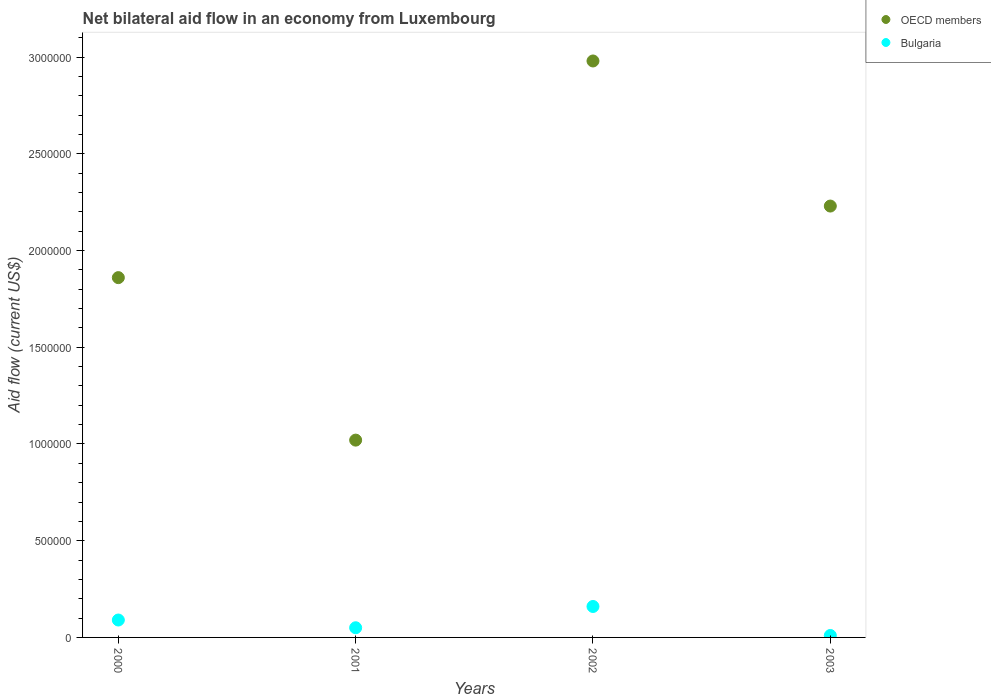How many different coloured dotlines are there?
Provide a short and direct response. 2. Is the number of dotlines equal to the number of legend labels?
Make the answer very short. Yes. What is the net bilateral aid flow in OECD members in 2003?
Provide a succinct answer. 2.23e+06. Across all years, what is the maximum net bilateral aid flow in Bulgaria?
Your answer should be compact. 1.60e+05. Across all years, what is the minimum net bilateral aid flow in Bulgaria?
Your response must be concise. 10000. In which year was the net bilateral aid flow in Bulgaria maximum?
Your answer should be compact. 2002. What is the total net bilateral aid flow in OECD members in the graph?
Provide a succinct answer. 8.09e+06. What is the difference between the net bilateral aid flow in OECD members in 2002 and the net bilateral aid flow in Bulgaria in 2003?
Your answer should be very brief. 2.97e+06. What is the average net bilateral aid flow in Bulgaria per year?
Offer a terse response. 7.75e+04. In the year 2000, what is the difference between the net bilateral aid flow in OECD members and net bilateral aid flow in Bulgaria?
Your answer should be compact. 1.77e+06. In how many years, is the net bilateral aid flow in OECD members greater than 2600000 US$?
Your answer should be very brief. 1. What is the ratio of the net bilateral aid flow in OECD members in 2001 to that in 2003?
Ensure brevity in your answer.  0.46. Is the difference between the net bilateral aid flow in OECD members in 2000 and 2002 greater than the difference between the net bilateral aid flow in Bulgaria in 2000 and 2002?
Your answer should be very brief. No. What is the difference between the highest and the second highest net bilateral aid flow in OECD members?
Ensure brevity in your answer.  7.50e+05. What is the difference between the highest and the lowest net bilateral aid flow in OECD members?
Offer a very short reply. 1.96e+06. Does the net bilateral aid flow in OECD members monotonically increase over the years?
Make the answer very short. No. Is the net bilateral aid flow in Bulgaria strictly greater than the net bilateral aid flow in OECD members over the years?
Make the answer very short. No. How many dotlines are there?
Provide a short and direct response. 2. How many years are there in the graph?
Offer a terse response. 4. What is the difference between two consecutive major ticks on the Y-axis?
Make the answer very short. 5.00e+05. Where does the legend appear in the graph?
Your response must be concise. Top right. How many legend labels are there?
Ensure brevity in your answer.  2. What is the title of the graph?
Your response must be concise. Net bilateral aid flow in an economy from Luxembourg. Does "Spain" appear as one of the legend labels in the graph?
Offer a terse response. No. What is the label or title of the X-axis?
Provide a short and direct response. Years. What is the label or title of the Y-axis?
Keep it short and to the point. Aid flow (current US$). What is the Aid flow (current US$) of OECD members in 2000?
Offer a very short reply. 1.86e+06. What is the Aid flow (current US$) in OECD members in 2001?
Provide a succinct answer. 1.02e+06. What is the Aid flow (current US$) in Bulgaria in 2001?
Your response must be concise. 5.00e+04. What is the Aid flow (current US$) in OECD members in 2002?
Ensure brevity in your answer.  2.98e+06. What is the Aid flow (current US$) in OECD members in 2003?
Your response must be concise. 2.23e+06. What is the Aid flow (current US$) in Bulgaria in 2003?
Make the answer very short. 10000. Across all years, what is the maximum Aid flow (current US$) of OECD members?
Offer a terse response. 2.98e+06. Across all years, what is the minimum Aid flow (current US$) of OECD members?
Your answer should be very brief. 1.02e+06. What is the total Aid flow (current US$) of OECD members in the graph?
Your answer should be very brief. 8.09e+06. What is the total Aid flow (current US$) in Bulgaria in the graph?
Ensure brevity in your answer.  3.10e+05. What is the difference between the Aid flow (current US$) in OECD members in 2000 and that in 2001?
Your answer should be very brief. 8.40e+05. What is the difference between the Aid flow (current US$) of OECD members in 2000 and that in 2002?
Provide a short and direct response. -1.12e+06. What is the difference between the Aid flow (current US$) in OECD members in 2000 and that in 2003?
Offer a very short reply. -3.70e+05. What is the difference between the Aid flow (current US$) of Bulgaria in 2000 and that in 2003?
Ensure brevity in your answer.  8.00e+04. What is the difference between the Aid flow (current US$) of OECD members in 2001 and that in 2002?
Your answer should be very brief. -1.96e+06. What is the difference between the Aid flow (current US$) in Bulgaria in 2001 and that in 2002?
Offer a very short reply. -1.10e+05. What is the difference between the Aid flow (current US$) in OECD members in 2001 and that in 2003?
Give a very brief answer. -1.21e+06. What is the difference between the Aid flow (current US$) in OECD members in 2002 and that in 2003?
Provide a short and direct response. 7.50e+05. What is the difference between the Aid flow (current US$) in OECD members in 2000 and the Aid flow (current US$) in Bulgaria in 2001?
Give a very brief answer. 1.81e+06. What is the difference between the Aid flow (current US$) of OECD members in 2000 and the Aid flow (current US$) of Bulgaria in 2002?
Your response must be concise. 1.70e+06. What is the difference between the Aid flow (current US$) of OECD members in 2000 and the Aid flow (current US$) of Bulgaria in 2003?
Offer a very short reply. 1.85e+06. What is the difference between the Aid flow (current US$) in OECD members in 2001 and the Aid flow (current US$) in Bulgaria in 2002?
Your answer should be very brief. 8.60e+05. What is the difference between the Aid flow (current US$) of OECD members in 2001 and the Aid flow (current US$) of Bulgaria in 2003?
Make the answer very short. 1.01e+06. What is the difference between the Aid flow (current US$) in OECD members in 2002 and the Aid flow (current US$) in Bulgaria in 2003?
Ensure brevity in your answer.  2.97e+06. What is the average Aid flow (current US$) of OECD members per year?
Offer a very short reply. 2.02e+06. What is the average Aid flow (current US$) of Bulgaria per year?
Make the answer very short. 7.75e+04. In the year 2000, what is the difference between the Aid flow (current US$) of OECD members and Aid flow (current US$) of Bulgaria?
Ensure brevity in your answer.  1.77e+06. In the year 2001, what is the difference between the Aid flow (current US$) in OECD members and Aid flow (current US$) in Bulgaria?
Make the answer very short. 9.70e+05. In the year 2002, what is the difference between the Aid flow (current US$) of OECD members and Aid flow (current US$) of Bulgaria?
Ensure brevity in your answer.  2.82e+06. In the year 2003, what is the difference between the Aid flow (current US$) in OECD members and Aid flow (current US$) in Bulgaria?
Provide a short and direct response. 2.22e+06. What is the ratio of the Aid flow (current US$) in OECD members in 2000 to that in 2001?
Provide a succinct answer. 1.82. What is the ratio of the Aid flow (current US$) in OECD members in 2000 to that in 2002?
Provide a short and direct response. 0.62. What is the ratio of the Aid flow (current US$) in Bulgaria in 2000 to that in 2002?
Make the answer very short. 0.56. What is the ratio of the Aid flow (current US$) of OECD members in 2000 to that in 2003?
Your response must be concise. 0.83. What is the ratio of the Aid flow (current US$) in OECD members in 2001 to that in 2002?
Make the answer very short. 0.34. What is the ratio of the Aid flow (current US$) in Bulgaria in 2001 to that in 2002?
Keep it short and to the point. 0.31. What is the ratio of the Aid flow (current US$) in OECD members in 2001 to that in 2003?
Provide a succinct answer. 0.46. What is the ratio of the Aid flow (current US$) in OECD members in 2002 to that in 2003?
Offer a terse response. 1.34. What is the ratio of the Aid flow (current US$) in Bulgaria in 2002 to that in 2003?
Ensure brevity in your answer.  16. What is the difference between the highest and the second highest Aid flow (current US$) in OECD members?
Give a very brief answer. 7.50e+05. What is the difference between the highest and the second highest Aid flow (current US$) in Bulgaria?
Provide a succinct answer. 7.00e+04. What is the difference between the highest and the lowest Aid flow (current US$) in OECD members?
Offer a terse response. 1.96e+06. 